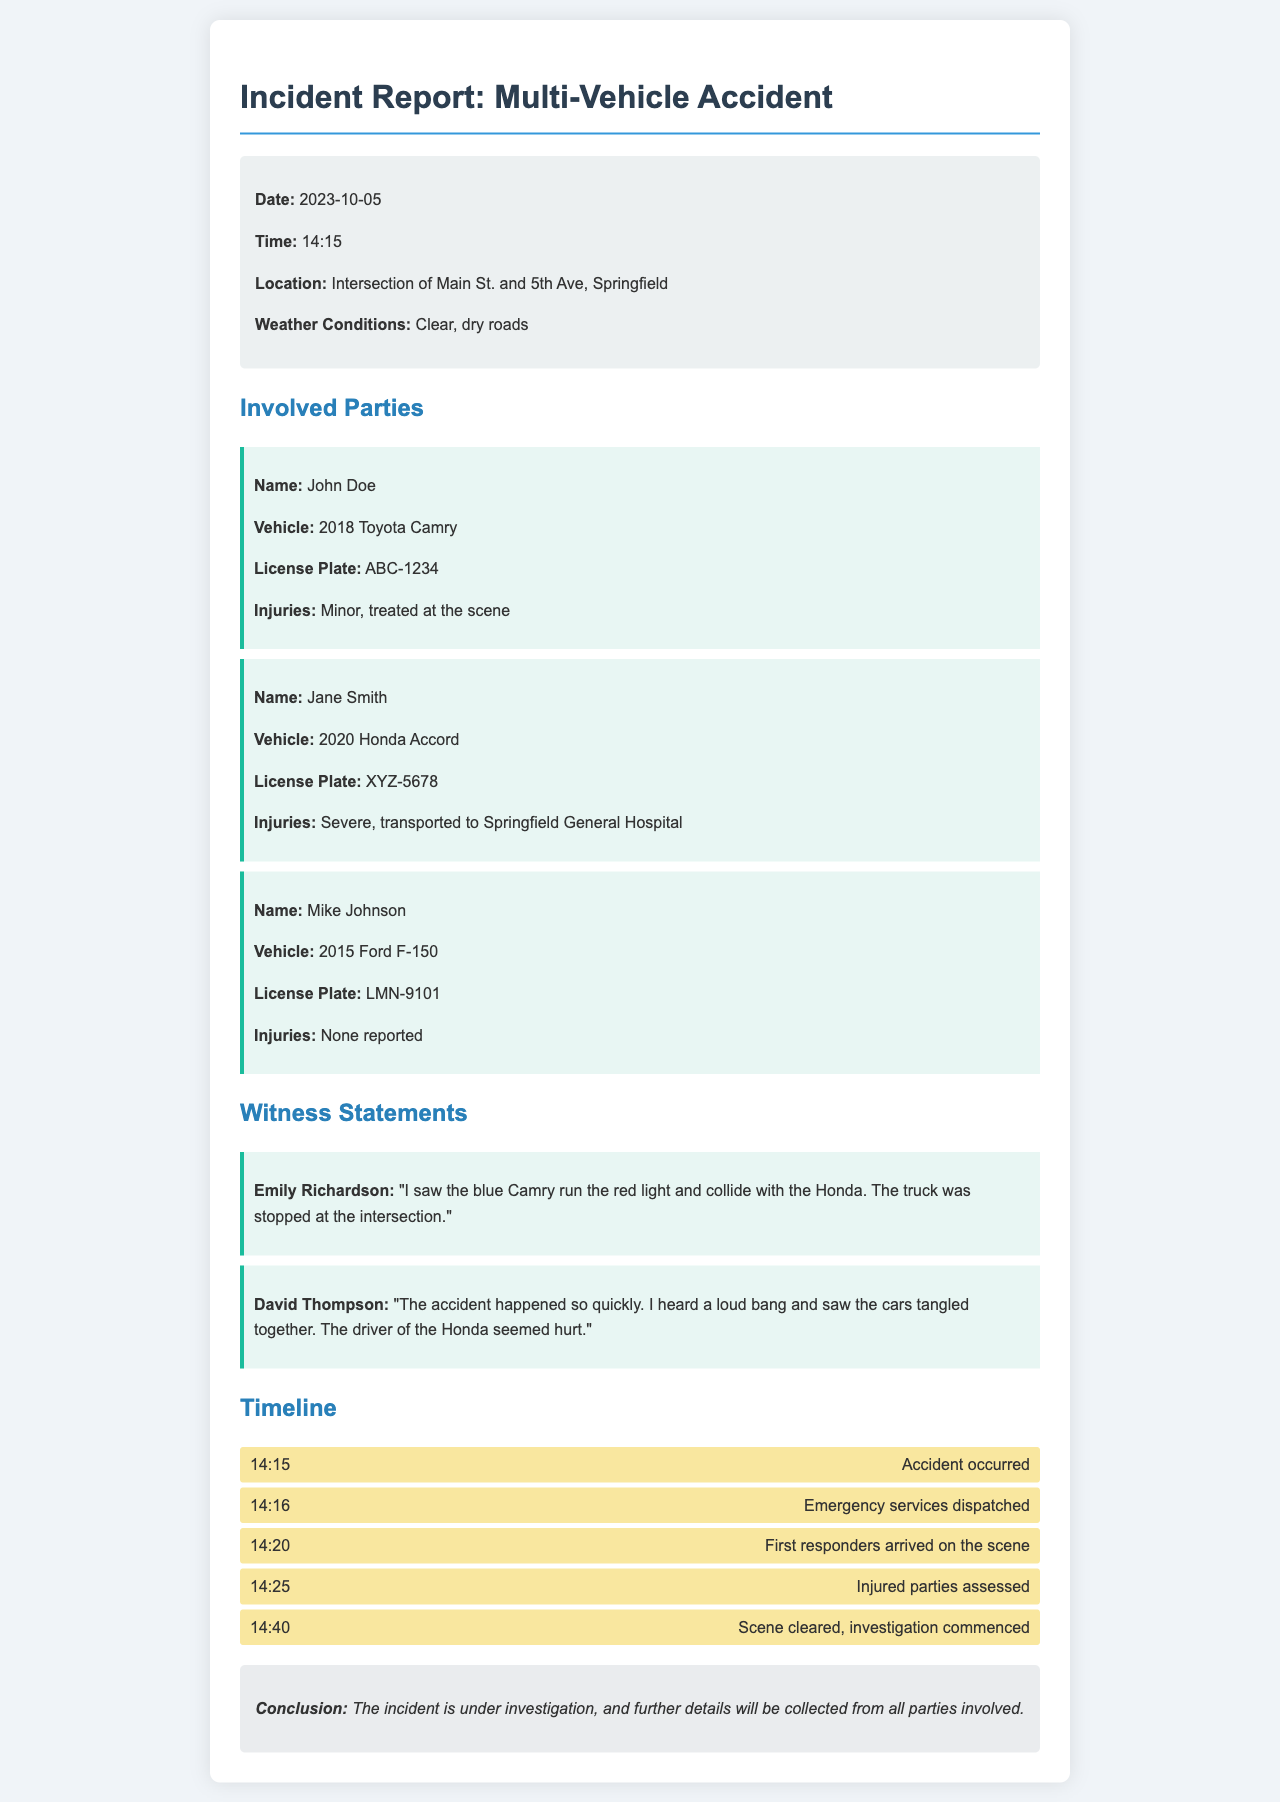What date did the accident occur? The date of the accident is explicitly stated in the document under incident details.
Answer: 2023-10-05 What time did the accident happen? The time of the accident is provided in the incident details section.
Answer: 14:15 How many vehicles were involved in the accident? The document lists three involved parties, each with a vehicle.
Answer: Three What were the weather conditions during the incident? The weather conditions are mentioned in the incident details section.
Answer: Clear, dry roads Who suffered severe injuries? The document states the injuries for each involved party, highlighting Jane Smith's condition.
Answer: Jane Smith What vehicle did John Doe drive? The involved party section lists the vehicle associated with John Doe.
Answer: 2018 Toyota Camry What statement did Emily Richardson provide? The witness statements section includes a direct quote from Emily Richardson regarding what she saw.
Answer: "I saw the blue Camry run the red light and collide with the Honda. The truck was stopped at the intersection." What time did emergency services get dispatched? The timeline section indicates when emergency services were dispatched after the accident.
Answer: 14:16 What conclusion is provided at the end of the report? The conclusion summarizes the state of the investigation, which is found at the bottom of the document.
Answer: The incident is under investigation, and further details will be collected from all parties involved 